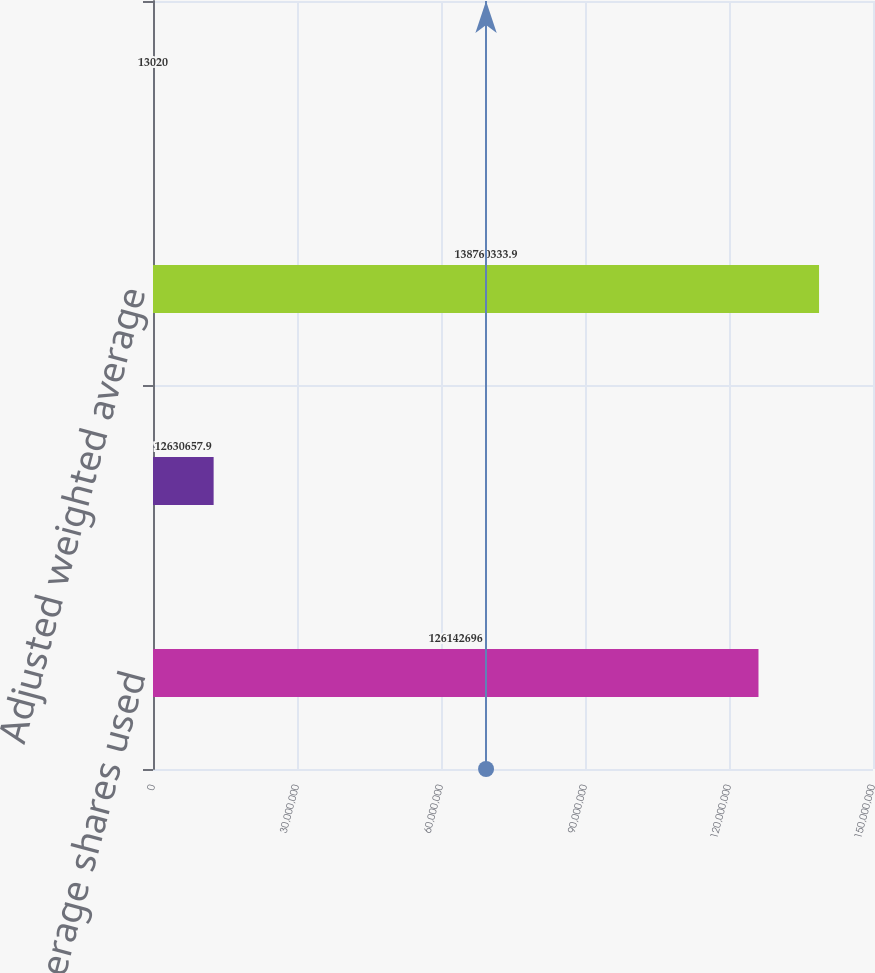Convert chart. <chart><loc_0><loc_0><loc_500><loc_500><bar_chart><fcel>Weighted average shares used<fcel>Incremental shares from<fcel>Adjusted weighted average<fcel>Unvested shares from<nl><fcel>1.26143e+08<fcel>1.26307e+07<fcel>1.3876e+08<fcel>13020<nl></chart> 